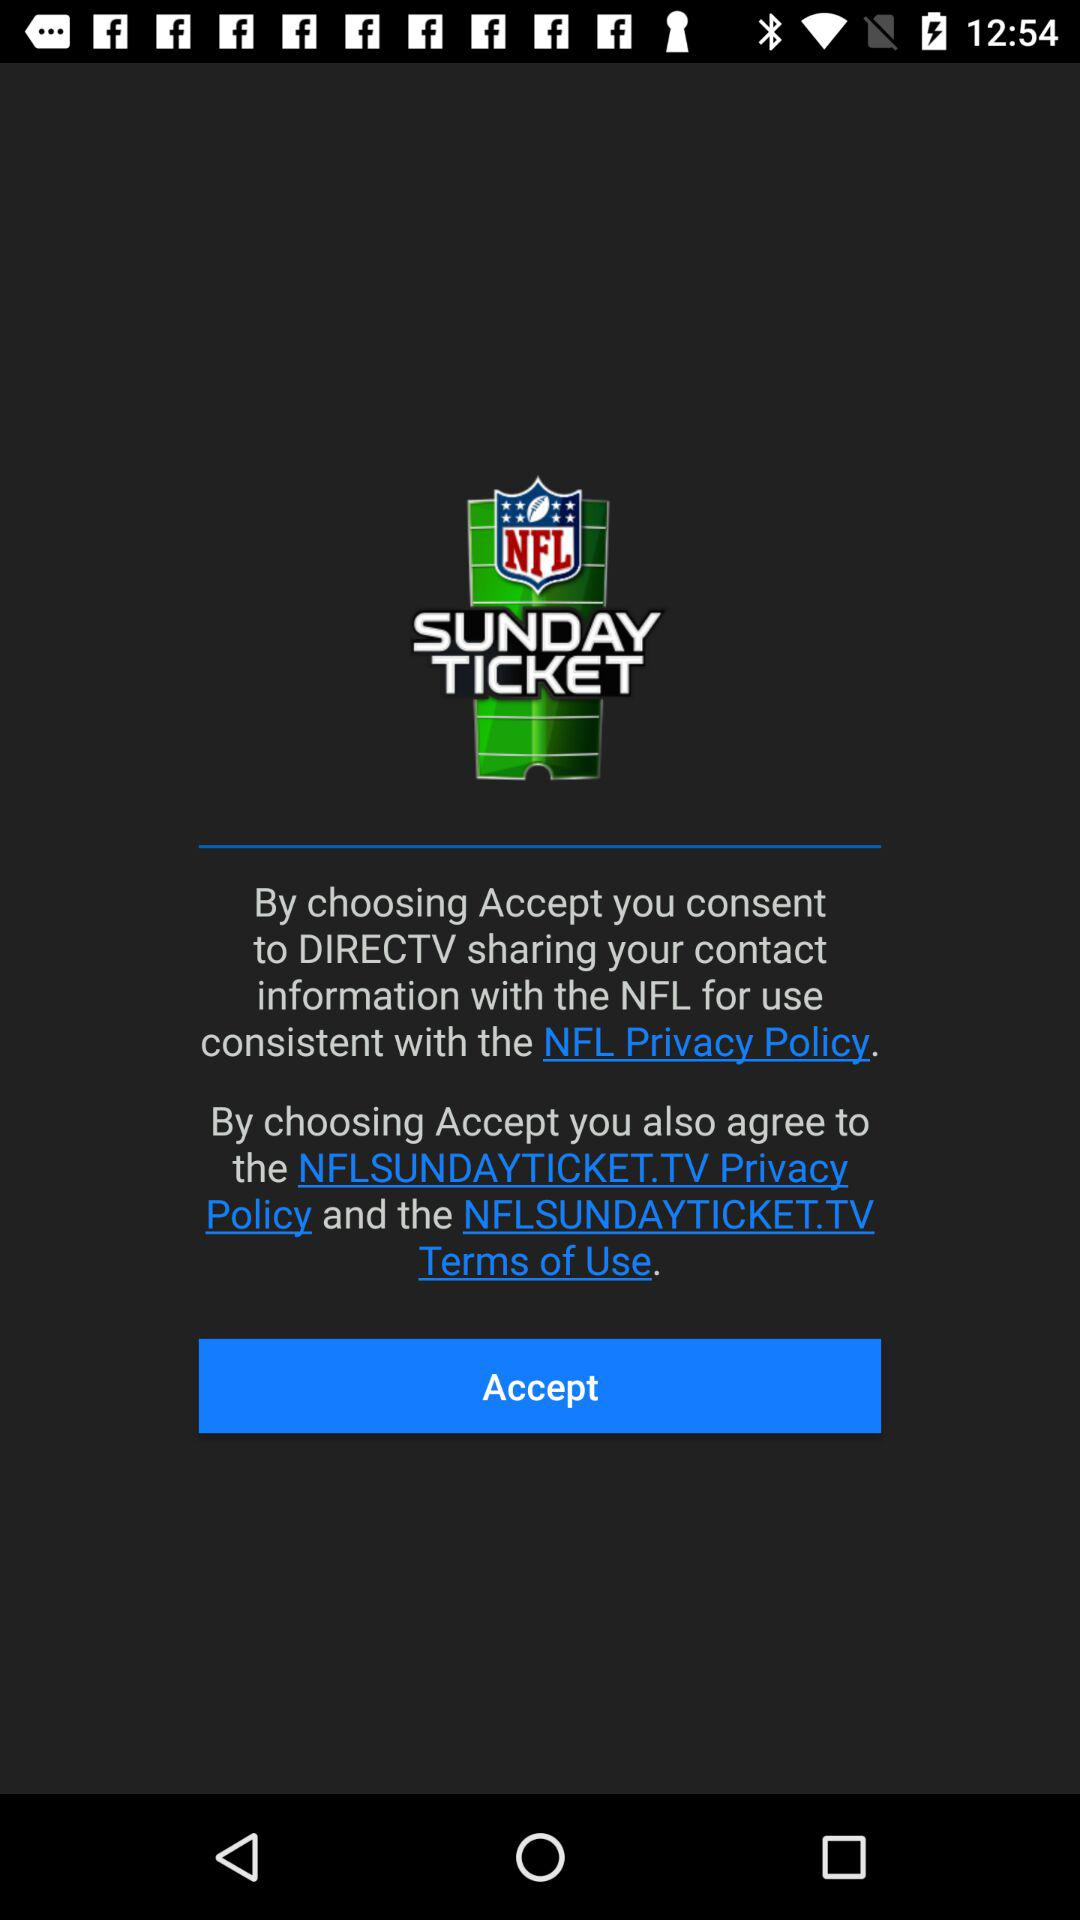What is the name of the application? The name of the application is "NFL SUNDAY TICKET". 